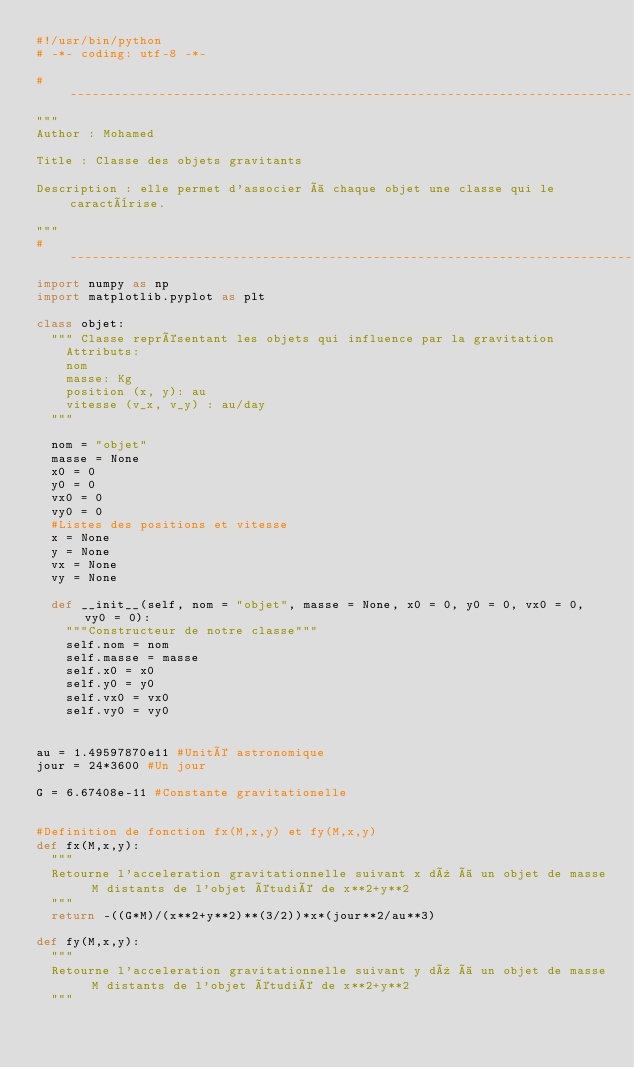Convert code to text. <code><loc_0><loc_0><loc_500><loc_500><_Python_>#!/usr/bin/python
# -*- coding: utf-8 -*-

#----------------------------------------------------------------------------------------------------------
"""
Author : Mohamed

Title : Classe des objets gravitants

Description : elle permet d'associer à chaque objet une classe qui le caractèrise.

"""
#-----------------------------------------------------------------------------------------------------------
import numpy as np
import matplotlib.pyplot as plt

class objet:
	""" Classe représentant les objets qui influence par la gravitation
		Attributs:
		nom 
		masse: Kg
		position (x, y): au
		vitesse (v_x, v_y) : au/day
	"""

	nom = "objet"
	masse = None
	x0 = 0
	y0 = 0
	vx0 = 0
	vy0 = 0
	#Listes des positions et vitesse 
	x = None 
	y = None
	vx = None
	vy = None 

	def __init__(self, nom = "objet", masse = None, x0 = 0, y0 = 0, vx0 = 0, vy0 = 0):
		"""Constructeur de notre classe"""
		self.nom = nom
		self.masse = masse
		self.x0 = x0
		self.y0 = y0
		self.vx0 = vx0
		self.vy0 = vy0


au = 1.49597870e11 #Unité astronomique
jour = 24*3600 #Un jour

G = 6.67408e-11 #Constante gravitationelle 


#Definition de fonction fx(M,x,y) et fy(M,x,y)
def fx(M,x,y):
	"""
	Retourne l'acceleration gravitationnelle suivant x dû à un objet de masse M distants de l'objet étudié de x**2+y**2
	"""
	return -((G*M)/(x**2+y**2)**(3/2))*x*(jour**2/au**3)

def fy(M,x,y):
	"""
	Retourne l'acceleration gravitationnelle suivant y dû à un objet de masse M distants de l'objet étudié de x**2+y**2
	"""</code> 